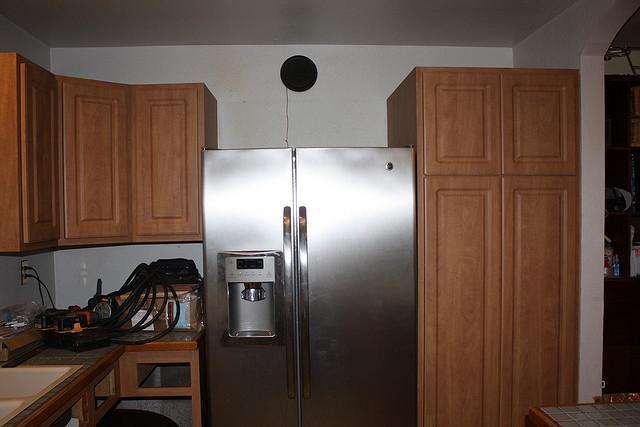How many refrigerators are there?
Give a very brief answer. 1. 